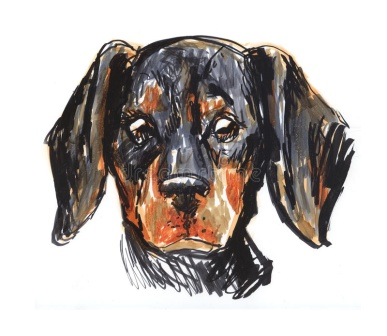The puppy looks so sad. What could be done to cheer it up? To cheer up the sad puppy, providing it with some loving attention and playtime would be ideal. A delightful game of fetch in the backyard could immediately bring a sparkle to its eyes. Soft, affectionate petting and gentle words of reassurance would help it feel loved and secure. Introducing it to a variety of toys, such as squeaky balls and chewable plushies, can also arouse its playful spirit. Lastly, offering a delicious treat and a cozy spot to snuggle, perhaps by a warm fire, would comfort the puppy and lift its spirits. Let’s give a name to the puppy and create a story about its adventures. The puppy’s name is Winston. Winston lived in a quaint village by the sea, known for its vibrant sunsets and sandy beaches. One day, Winston spotted a shiny, golden seashell washed ashore. Intrigued, he picked it up and to his surprise, the seashell began to glow. Suddenly, Winston was able to understand and communicate with marine creatures. Every night, under the starry sky, he embarked on underwater adventures, guided by his newfound friends—Daisy the seahorse, Finn the dolphin, and Oliver the octopus. Together, they explored hidden reefs, discovered sunken treasures, and protected the sea from any threats. Winston became a legendary guardian of the ocean, adored by both the villagers and his aquatic companions. His days were filled with joy and excitement, knowing that each sunset brought another magical journey beneath the waves. 